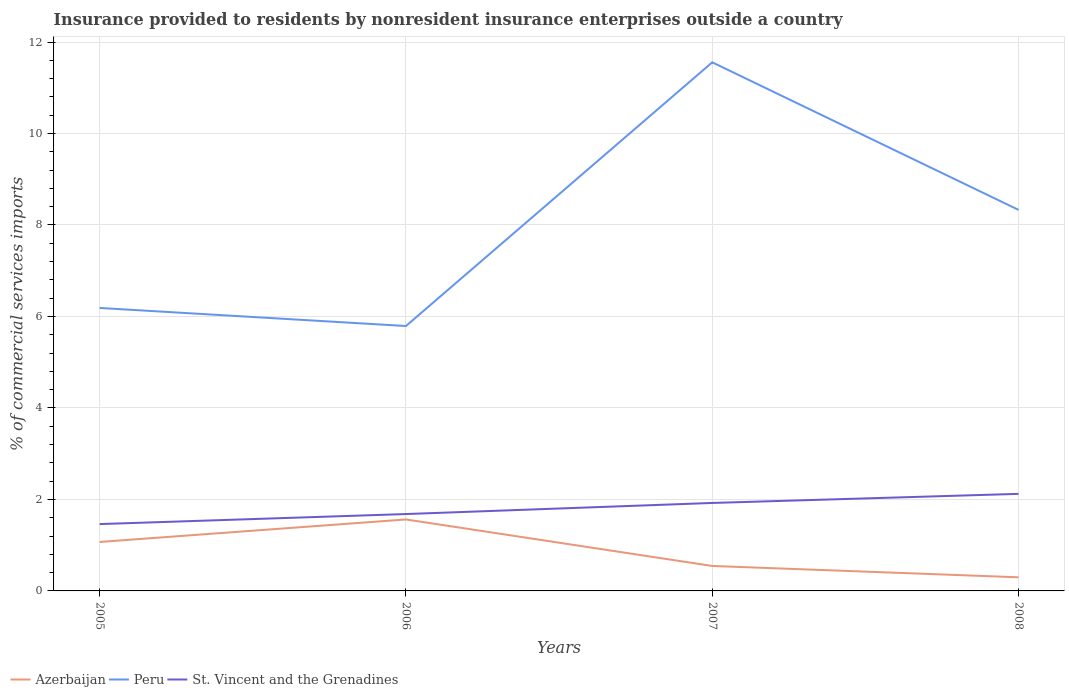How many different coloured lines are there?
Give a very brief answer. 3. Does the line corresponding to Azerbaijan intersect with the line corresponding to St. Vincent and the Grenadines?
Your answer should be very brief. No. Is the number of lines equal to the number of legend labels?
Provide a short and direct response. Yes. Across all years, what is the maximum Insurance provided to residents in St. Vincent and the Grenadines?
Provide a succinct answer. 1.46. In which year was the Insurance provided to residents in Peru maximum?
Provide a short and direct response. 2006. What is the total Insurance provided to residents in Peru in the graph?
Provide a short and direct response. -2.14. What is the difference between the highest and the second highest Insurance provided to residents in Azerbaijan?
Give a very brief answer. 1.26. Is the Insurance provided to residents in Peru strictly greater than the Insurance provided to residents in Azerbaijan over the years?
Provide a succinct answer. No. How many years are there in the graph?
Give a very brief answer. 4. What is the difference between two consecutive major ticks on the Y-axis?
Your response must be concise. 2. Does the graph contain grids?
Provide a succinct answer. Yes. Where does the legend appear in the graph?
Offer a very short reply. Bottom left. How many legend labels are there?
Your answer should be compact. 3. How are the legend labels stacked?
Provide a succinct answer. Horizontal. What is the title of the graph?
Keep it short and to the point. Insurance provided to residents by nonresident insurance enterprises outside a country. What is the label or title of the X-axis?
Provide a succinct answer. Years. What is the label or title of the Y-axis?
Give a very brief answer. % of commercial services imports. What is the % of commercial services imports in Azerbaijan in 2005?
Provide a short and direct response. 1.07. What is the % of commercial services imports of Peru in 2005?
Offer a terse response. 6.19. What is the % of commercial services imports in St. Vincent and the Grenadines in 2005?
Ensure brevity in your answer.  1.46. What is the % of commercial services imports in Azerbaijan in 2006?
Keep it short and to the point. 1.56. What is the % of commercial services imports in Peru in 2006?
Provide a short and direct response. 5.79. What is the % of commercial services imports in St. Vincent and the Grenadines in 2006?
Keep it short and to the point. 1.68. What is the % of commercial services imports in Azerbaijan in 2007?
Make the answer very short. 0.55. What is the % of commercial services imports in Peru in 2007?
Your response must be concise. 11.56. What is the % of commercial services imports in St. Vincent and the Grenadines in 2007?
Keep it short and to the point. 1.92. What is the % of commercial services imports of Azerbaijan in 2008?
Your response must be concise. 0.3. What is the % of commercial services imports in Peru in 2008?
Your response must be concise. 8.33. What is the % of commercial services imports of St. Vincent and the Grenadines in 2008?
Provide a succinct answer. 2.12. Across all years, what is the maximum % of commercial services imports of Azerbaijan?
Your answer should be very brief. 1.56. Across all years, what is the maximum % of commercial services imports in Peru?
Provide a succinct answer. 11.56. Across all years, what is the maximum % of commercial services imports in St. Vincent and the Grenadines?
Your answer should be very brief. 2.12. Across all years, what is the minimum % of commercial services imports in Azerbaijan?
Make the answer very short. 0.3. Across all years, what is the minimum % of commercial services imports of Peru?
Provide a short and direct response. 5.79. Across all years, what is the minimum % of commercial services imports in St. Vincent and the Grenadines?
Give a very brief answer. 1.46. What is the total % of commercial services imports of Azerbaijan in the graph?
Provide a succinct answer. 3.48. What is the total % of commercial services imports of Peru in the graph?
Offer a very short reply. 31.86. What is the total % of commercial services imports of St. Vincent and the Grenadines in the graph?
Provide a succinct answer. 7.19. What is the difference between the % of commercial services imports of Azerbaijan in 2005 and that in 2006?
Make the answer very short. -0.49. What is the difference between the % of commercial services imports of Peru in 2005 and that in 2006?
Ensure brevity in your answer.  0.39. What is the difference between the % of commercial services imports in St. Vincent and the Grenadines in 2005 and that in 2006?
Ensure brevity in your answer.  -0.22. What is the difference between the % of commercial services imports in Azerbaijan in 2005 and that in 2007?
Give a very brief answer. 0.52. What is the difference between the % of commercial services imports of Peru in 2005 and that in 2007?
Give a very brief answer. -5.37. What is the difference between the % of commercial services imports of St. Vincent and the Grenadines in 2005 and that in 2007?
Your answer should be very brief. -0.46. What is the difference between the % of commercial services imports of Azerbaijan in 2005 and that in 2008?
Provide a short and direct response. 0.77. What is the difference between the % of commercial services imports in Peru in 2005 and that in 2008?
Keep it short and to the point. -2.14. What is the difference between the % of commercial services imports of St. Vincent and the Grenadines in 2005 and that in 2008?
Provide a short and direct response. -0.66. What is the difference between the % of commercial services imports of Azerbaijan in 2006 and that in 2007?
Your answer should be compact. 1.02. What is the difference between the % of commercial services imports of Peru in 2006 and that in 2007?
Make the answer very short. -5.76. What is the difference between the % of commercial services imports of St. Vincent and the Grenadines in 2006 and that in 2007?
Ensure brevity in your answer.  -0.24. What is the difference between the % of commercial services imports in Azerbaijan in 2006 and that in 2008?
Offer a terse response. 1.26. What is the difference between the % of commercial services imports in Peru in 2006 and that in 2008?
Your response must be concise. -2.54. What is the difference between the % of commercial services imports in St. Vincent and the Grenadines in 2006 and that in 2008?
Your response must be concise. -0.44. What is the difference between the % of commercial services imports in Azerbaijan in 2007 and that in 2008?
Your answer should be compact. 0.25. What is the difference between the % of commercial services imports of Peru in 2007 and that in 2008?
Provide a short and direct response. 3.23. What is the difference between the % of commercial services imports in St. Vincent and the Grenadines in 2007 and that in 2008?
Provide a short and direct response. -0.2. What is the difference between the % of commercial services imports of Azerbaijan in 2005 and the % of commercial services imports of Peru in 2006?
Offer a very short reply. -4.72. What is the difference between the % of commercial services imports of Azerbaijan in 2005 and the % of commercial services imports of St. Vincent and the Grenadines in 2006?
Keep it short and to the point. -0.61. What is the difference between the % of commercial services imports of Peru in 2005 and the % of commercial services imports of St. Vincent and the Grenadines in 2006?
Offer a very short reply. 4.51. What is the difference between the % of commercial services imports in Azerbaijan in 2005 and the % of commercial services imports in Peru in 2007?
Make the answer very short. -10.49. What is the difference between the % of commercial services imports of Azerbaijan in 2005 and the % of commercial services imports of St. Vincent and the Grenadines in 2007?
Ensure brevity in your answer.  -0.85. What is the difference between the % of commercial services imports in Peru in 2005 and the % of commercial services imports in St. Vincent and the Grenadines in 2007?
Your answer should be very brief. 4.26. What is the difference between the % of commercial services imports in Azerbaijan in 2005 and the % of commercial services imports in Peru in 2008?
Offer a very short reply. -7.26. What is the difference between the % of commercial services imports of Azerbaijan in 2005 and the % of commercial services imports of St. Vincent and the Grenadines in 2008?
Offer a terse response. -1.05. What is the difference between the % of commercial services imports of Peru in 2005 and the % of commercial services imports of St. Vincent and the Grenadines in 2008?
Ensure brevity in your answer.  4.06. What is the difference between the % of commercial services imports in Azerbaijan in 2006 and the % of commercial services imports in Peru in 2007?
Your answer should be compact. -9.99. What is the difference between the % of commercial services imports in Azerbaijan in 2006 and the % of commercial services imports in St. Vincent and the Grenadines in 2007?
Your answer should be very brief. -0.36. What is the difference between the % of commercial services imports in Peru in 2006 and the % of commercial services imports in St. Vincent and the Grenadines in 2007?
Your response must be concise. 3.87. What is the difference between the % of commercial services imports of Azerbaijan in 2006 and the % of commercial services imports of Peru in 2008?
Make the answer very short. -6.77. What is the difference between the % of commercial services imports in Azerbaijan in 2006 and the % of commercial services imports in St. Vincent and the Grenadines in 2008?
Give a very brief answer. -0.56. What is the difference between the % of commercial services imports of Peru in 2006 and the % of commercial services imports of St. Vincent and the Grenadines in 2008?
Your answer should be compact. 3.67. What is the difference between the % of commercial services imports in Azerbaijan in 2007 and the % of commercial services imports in Peru in 2008?
Make the answer very short. -7.78. What is the difference between the % of commercial services imports of Azerbaijan in 2007 and the % of commercial services imports of St. Vincent and the Grenadines in 2008?
Keep it short and to the point. -1.58. What is the difference between the % of commercial services imports of Peru in 2007 and the % of commercial services imports of St. Vincent and the Grenadines in 2008?
Provide a succinct answer. 9.43. What is the average % of commercial services imports of Azerbaijan per year?
Your response must be concise. 0.87. What is the average % of commercial services imports of Peru per year?
Provide a short and direct response. 7.97. What is the average % of commercial services imports of St. Vincent and the Grenadines per year?
Provide a short and direct response. 1.8. In the year 2005, what is the difference between the % of commercial services imports of Azerbaijan and % of commercial services imports of Peru?
Keep it short and to the point. -5.12. In the year 2005, what is the difference between the % of commercial services imports in Azerbaijan and % of commercial services imports in St. Vincent and the Grenadines?
Make the answer very short. -0.39. In the year 2005, what is the difference between the % of commercial services imports in Peru and % of commercial services imports in St. Vincent and the Grenadines?
Offer a very short reply. 4.72. In the year 2006, what is the difference between the % of commercial services imports of Azerbaijan and % of commercial services imports of Peru?
Provide a short and direct response. -4.23. In the year 2006, what is the difference between the % of commercial services imports in Azerbaijan and % of commercial services imports in St. Vincent and the Grenadines?
Provide a short and direct response. -0.12. In the year 2006, what is the difference between the % of commercial services imports of Peru and % of commercial services imports of St. Vincent and the Grenadines?
Provide a short and direct response. 4.11. In the year 2007, what is the difference between the % of commercial services imports in Azerbaijan and % of commercial services imports in Peru?
Make the answer very short. -11.01. In the year 2007, what is the difference between the % of commercial services imports of Azerbaijan and % of commercial services imports of St. Vincent and the Grenadines?
Provide a short and direct response. -1.38. In the year 2007, what is the difference between the % of commercial services imports in Peru and % of commercial services imports in St. Vincent and the Grenadines?
Offer a terse response. 9.63. In the year 2008, what is the difference between the % of commercial services imports of Azerbaijan and % of commercial services imports of Peru?
Give a very brief answer. -8.03. In the year 2008, what is the difference between the % of commercial services imports in Azerbaijan and % of commercial services imports in St. Vincent and the Grenadines?
Give a very brief answer. -1.82. In the year 2008, what is the difference between the % of commercial services imports of Peru and % of commercial services imports of St. Vincent and the Grenadines?
Offer a very short reply. 6.21. What is the ratio of the % of commercial services imports in Azerbaijan in 2005 to that in 2006?
Keep it short and to the point. 0.69. What is the ratio of the % of commercial services imports of Peru in 2005 to that in 2006?
Keep it short and to the point. 1.07. What is the ratio of the % of commercial services imports of St. Vincent and the Grenadines in 2005 to that in 2006?
Provide a short and direct response. 0.87. What is the ratio of the % of commercial services imports of Azerbaijan in 2005 to that in 2007?
Your answer should be compact. 1.96. What is the ratio of the % of commercial services imports in Peru in 2005 to that in 2007?
Your answer should be very brief. 0.54. What is the ratio of the % of commercial services imports of St. Vincent and the Grenadines in 2005 to that in 2007?
Your answer should be compact. 0.76. What is the ratio of the % of commercial services imports in Azerbaijan in 2005 to that in 2008?
Offer a terse response. 3.59. What is the ratio of the % of commercial services imports of Peru in 2005 to that in 2008?
Ensure brevity in your answer.  0.74. What is the ratio of the % of commercial services imports in St. Vincent and the Grenadines in 2005 to that in 2008?
Give a very brief answer. 0.69. What is the ratio of the % of commercial services imports in Azerbaijan in 2006 to that in 2007?
Your answer should be very brief. 2.86. What is the ratio of the % of commercial services imports of Peru in 2006 to that in 2007?
Provide a short and direct response. 0.5. What is the ratio of the % of commercial services imports in St. Vincent and the Grenadines in 2006 to that in 2007?
Keep it short and to the point. 0.87. What is the ratio of the % of commercial services imports of Azerbaijan in 2006 to that in 2008?
Offer a very short reply. 5.25. What is the ratio of the % of commercial services imports of Peru in 2006 to that in 2008?
Provide a short and direct response. 0.7. What is the ratio of the % of commercial services imports of St. Vincent and the Grenadines in 2006 to that in 2008?
Keep it short and to the point. 0.79. What is the ratio of the % of commercial services imports in Azerbaijan in 2007 to that in 2008?
Your answer should be very brief. 1.83. What is the ratio of the % of commercial services imports of Peru in 2007 to that in 2008?
Provide a succinct answer. 1.39. What is the ratio of the % of commercial services imports in St. Vincent and the Grenadines in 2007 to that in 2008?
Make the answer very short. 0.91. What is the difference between the highest and the second highest % of commercial services imports of Azerbaijan?
Keep it short and to the point. 0.49. What is the difference between the highest and the second highest % of commercial services imports in Peru?
Ensure brevity in your answer.  3.23. What is the difference between the highest and the second highest % of commercial services imports of St. Vincent and the Grenadines?
Ensure brevity in your answer.  0.2. What is the difference between the highest and the lowest % of commercial services imports in Azerbaijan?
Keep it short and to the point. 1.26. What is the difference between the highest and the lowest % of commercial services imports of Peru?
Offer a very short reply. 5.76. What is the difference between the highest and the lowest % of commercial services imports of St. Vincent and the Grenadines?
Your answer should be very brief. 0.66. 